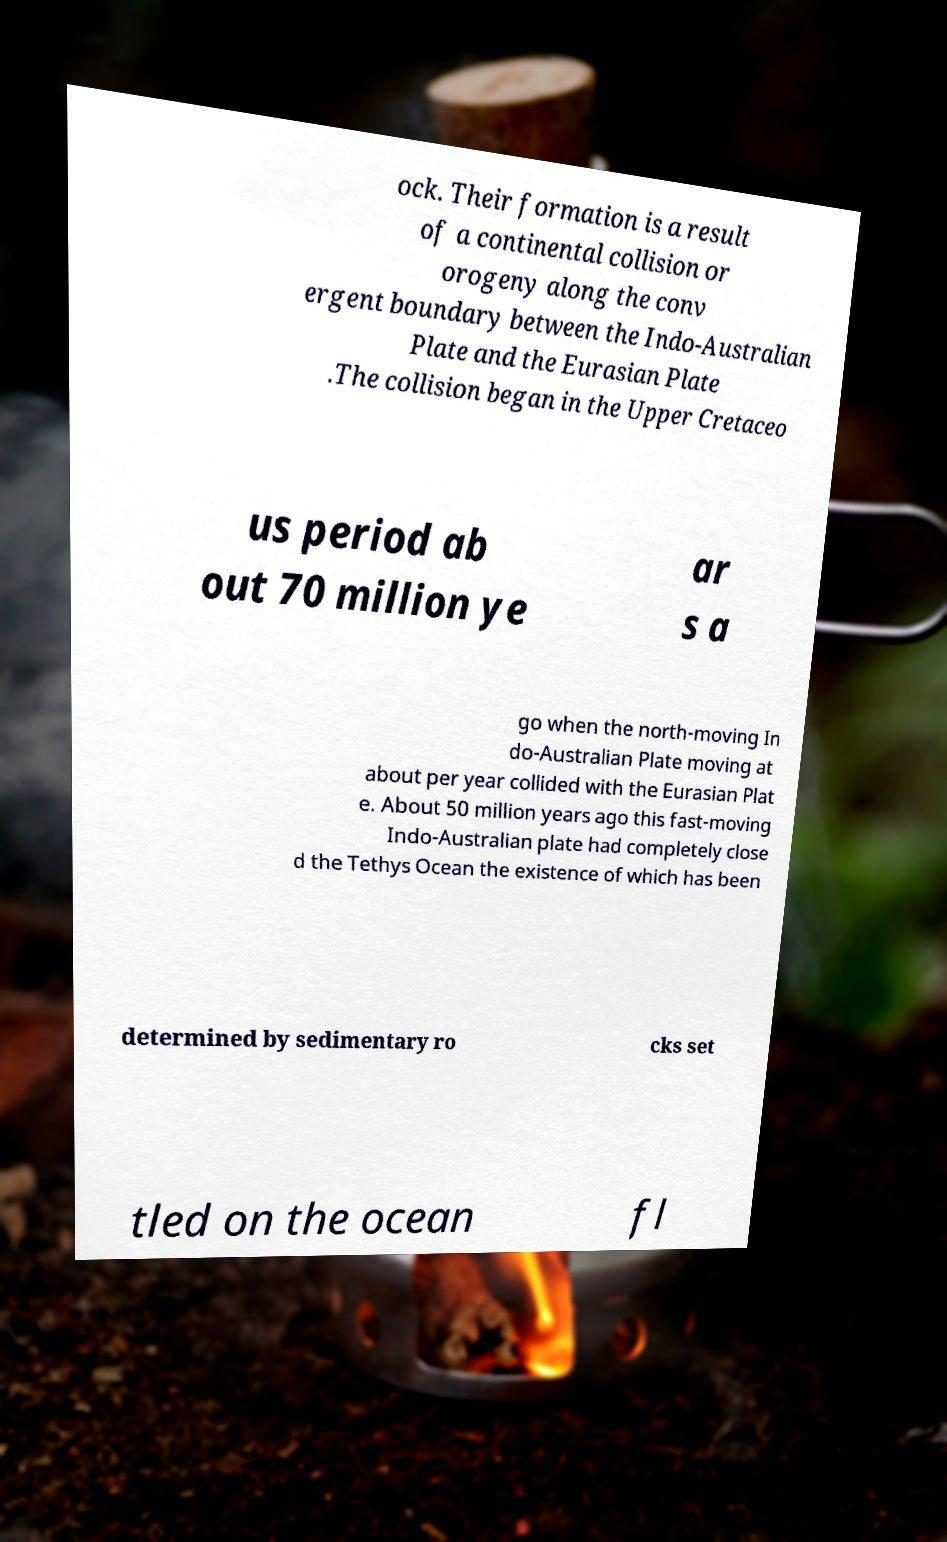There's text embedded in this image that I need extracted. Can you transcribe it verbatim? ock. Their formation is a result of a continental collision or orogeny along the conv ergent boundary between the Indo-Australian Plate and the Eurasian Plate .The collision began in the Upper Cretaceo us period ab out 70 million ye ar s a go when the north-moving In do-Australian Plate moving at about per year collided with the Eurasian Plat e. About 50 million years ago this fast-moving Indo-Australian plate had completely close d the Tethys Ocean the existence of which has been determined by sedimentary ro cks set tled on the ocean fl 